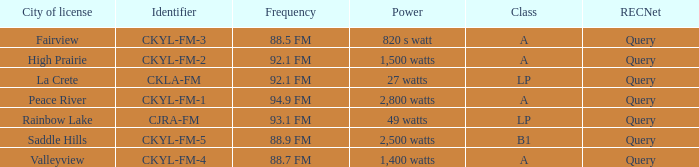Give me the full table as a dictionary. {'header': ['City of license', 'Identifier', 'Frequency', 'Power', 'Class', 'RECNet'], 'rows': [['Fairview', 'CKYL-FM-3', '88.5 FM', '820 s watt', 'A', 'Query'], ['High Prairie', 'CKYL-FM-2', '92.1 FM', '1,500 watts', 'A', 'Query'], ['La Crete', 'CKLA-FM', '92.1 FM', '27 watts', 'LP', 'Query'], ['Peace River', 'CKYL-FM-1', '94.9 FM', '2,800 watts', 'A', 'Query'], ['Rainbow Lake', 'CJRA-FM', '93.1 FM', '49 watts', 'LP', 'Query'], ['Saddle Hills', 'CKYL-FM-5', '88.9 FM', '2,500 watts', 'B1', 'Query'], ['Valleyview', 'CKYL-FM-4', '88.7 FM', '1,400 watts', 'A', 'Query']]} What is the power with 88.5 fm frequency 820 s watt. 